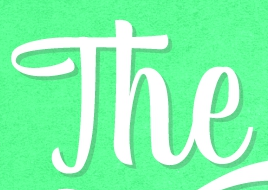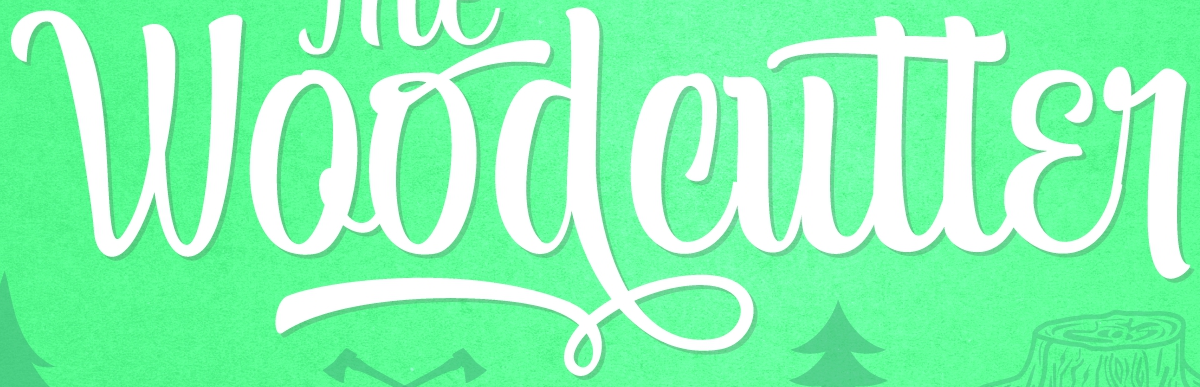Identify the words shown in these images in order, separated by a semicolon. The; Woodcutter 